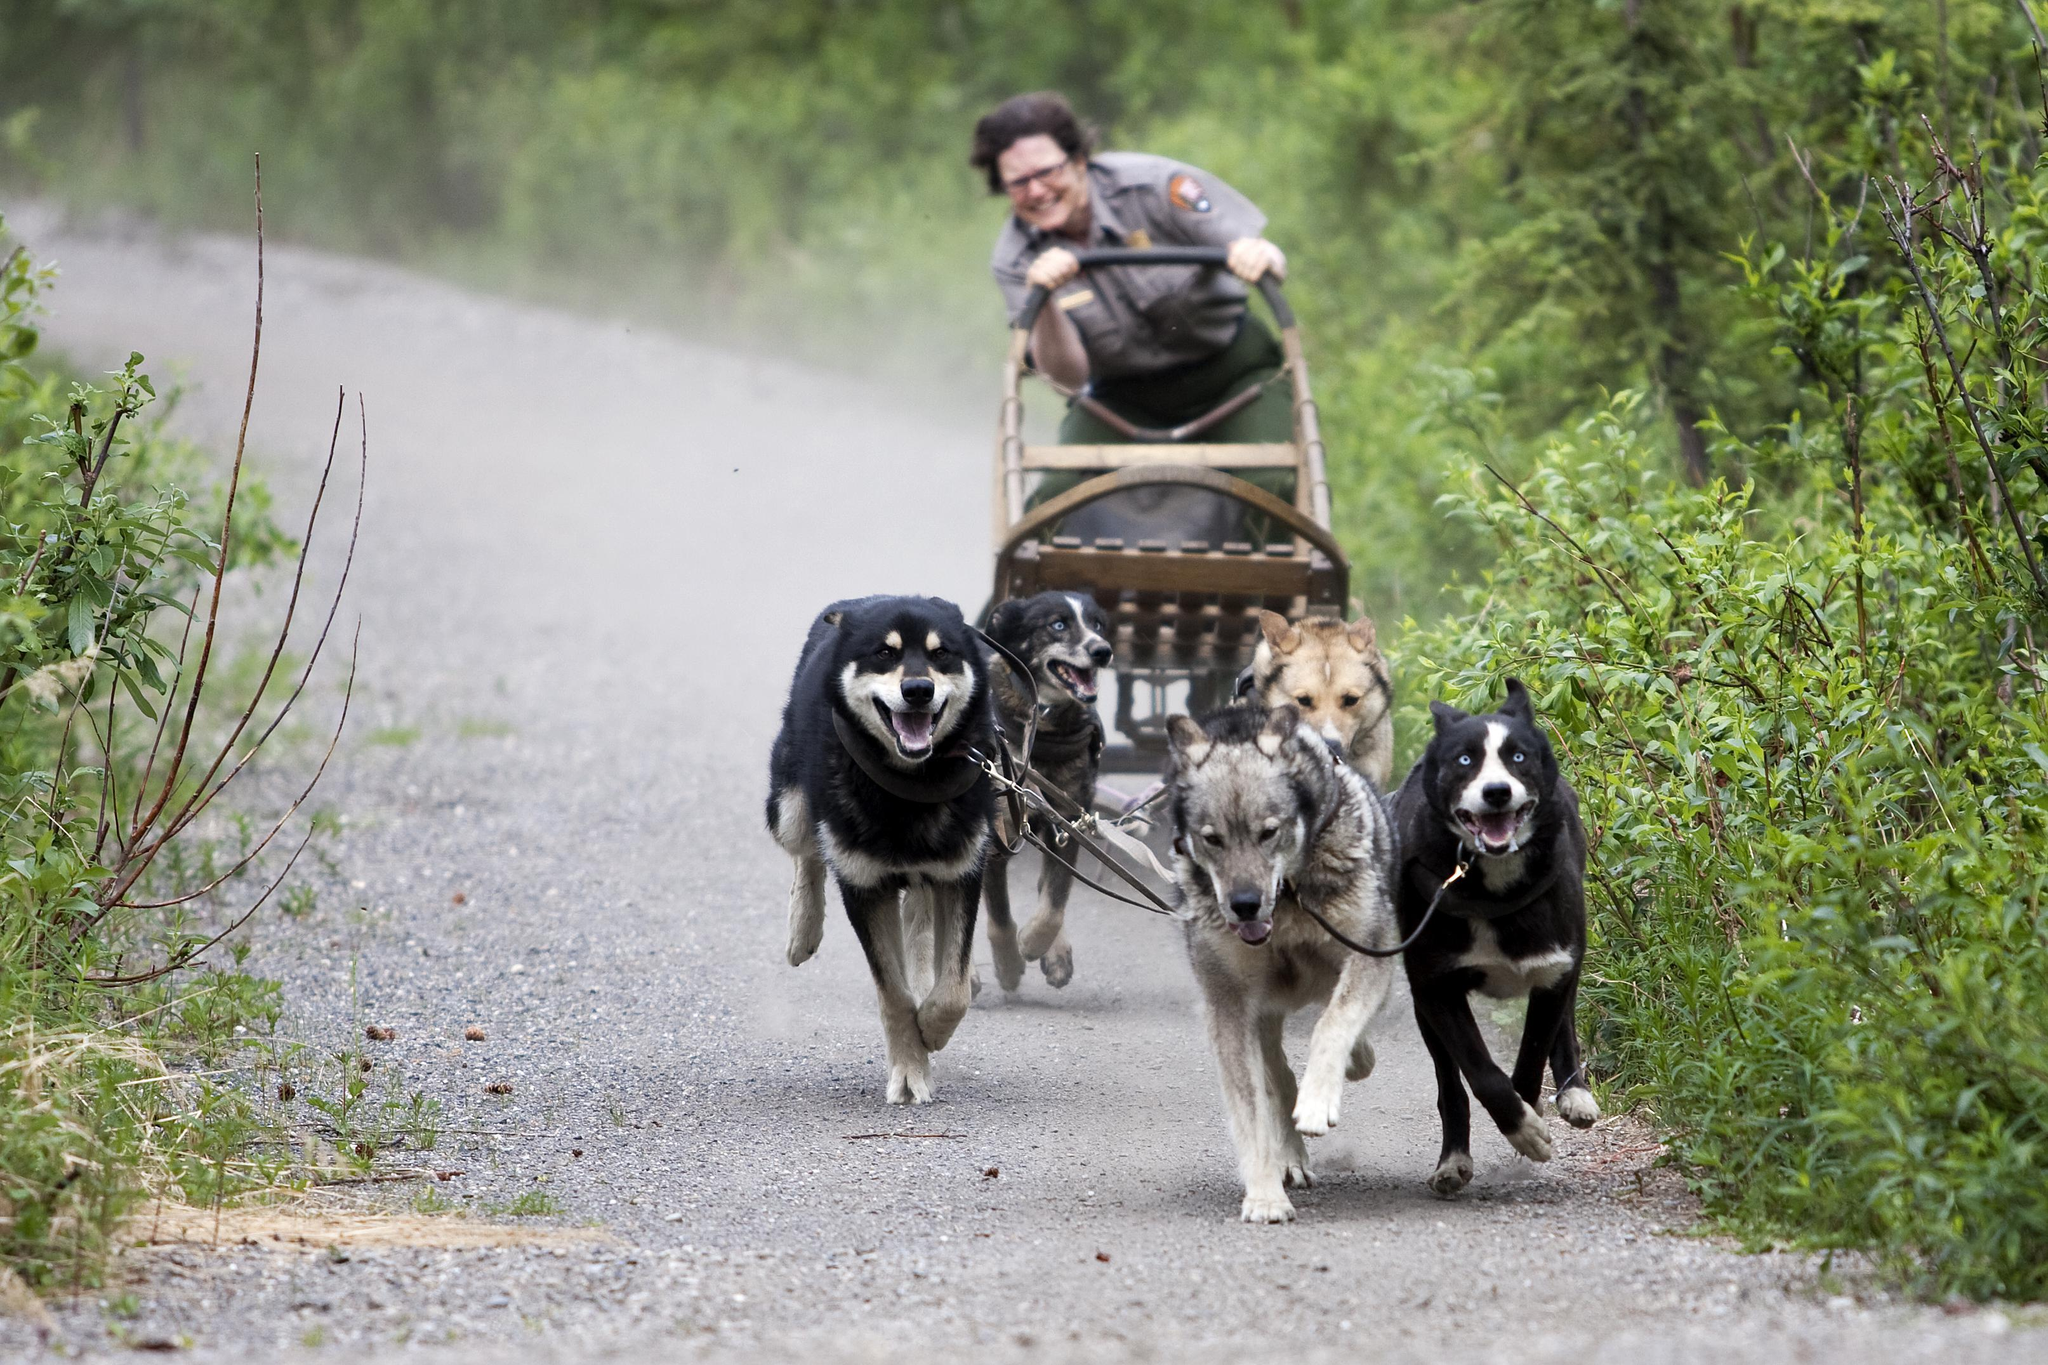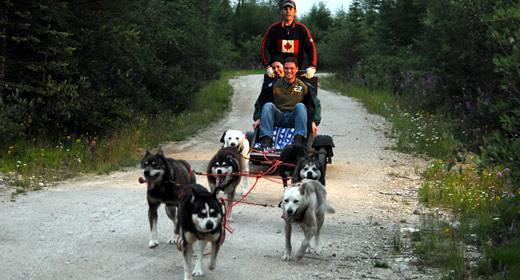The first image is the image on the left, the second image is the image on the right. Evaluate the accuracy of this statement regarding the images: "One of the sleds features a single rider.". Is it true? Answer yes or no. Yes. 